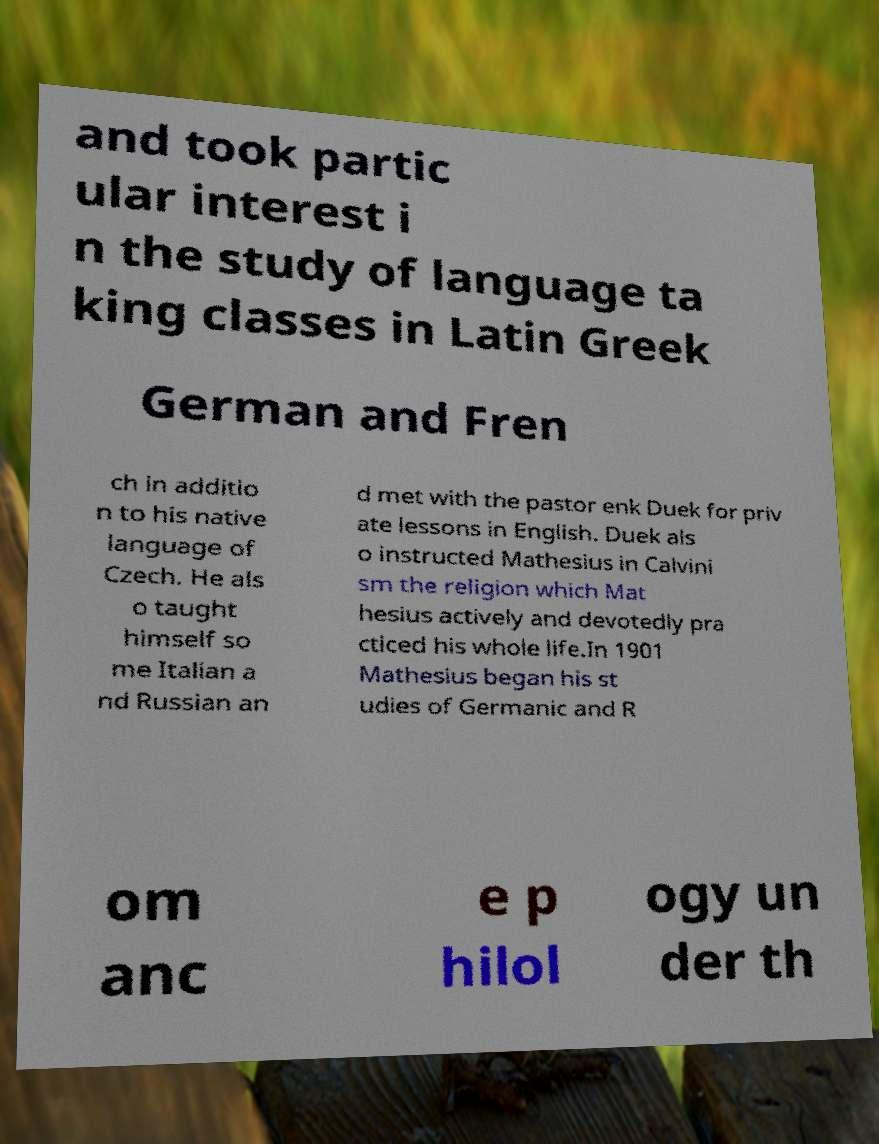Could you assist in decoding the text presented in this image and type it out clearly? and took partic ular interest i n the study of language ta king classes in Latin Greek German and Fren ch in additio n to his native language of Czech. He als o taught himself so me Italian a nd Russian an d met with the pastor enk Duek for priv ate lessons in English. Duek als o instructed Mathesius in Calvini sm the religion which Mat hesius actively and devotedly pra cticed his whole life.In 1901 Mathesius began his st udies of Germanic and R om anc e p hilol ogy un der th 